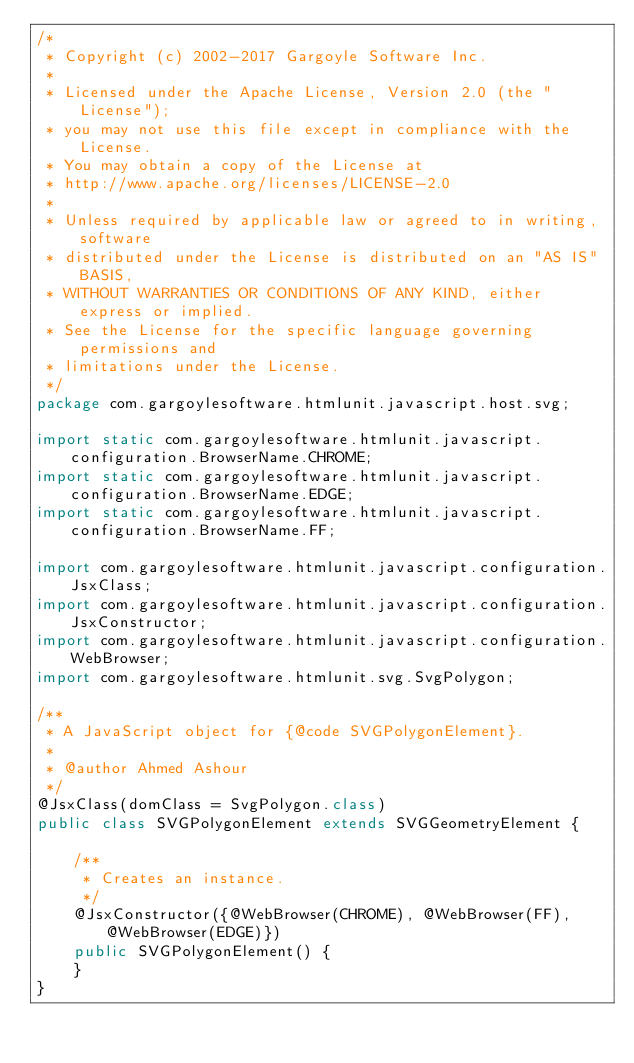Convert code to text. <code><loc_0><loc_0><loc_500><loc_500><_Java_>/*
 * Copyright (c) 2002-2017 Gargoyle Software Inc.
 *
 * Licensed under the Apache License, Version 2.0 (the "License");
 * you may not use this file except in compliance with the License.
 * You may obtain a copy of the License at
 * http://www.apache.org/licenses/LICENSE-2.0
 *
 * Unless required by applicable law or agreed to in writing, software
 * distributed under the License is distributed on an "AS IS" BASIS,
 * WITHOUT WARRANTIES OR CONDITIONS OF ANY KIND, either express or implied.
 * See the License for the specific language governing permissions and
 * limitations under the License.
 */
package com.gargoylesoftware.htmlunit.javascript.host.svg;

import static com.gargoylesoftware.htmlunit.javascript.configuration.BrowserName.CHROME;
import static com.gargoylesoftware.htmlunit.javascript.configuration.BrowserName.EDGE;
import static com.gargoylesoftware.htmlunit.javascript.configuration.BrowserName.FF;

import com.gargoylesoftware.htmlunit.javascript.configuration.JsxClass;
import com.gargoylesoftware.htmlunit.javascript.configuration.JsxConstructor;
import com.gargoylesoftware.htmlunit.javascript.configuration.WebBrowser;
import com.gargoylesoftware.htmlunit.svg.SvgPolygon;

/**
 * A JavaScript object for {@code SVGPolygonElement}.
 *
 * @author Ahmed Ashour
 */
@JsxClass(domClass = SvgPolygon.class)
public class SVGPolygonElement extends SVGGeometryElement {

    /**
     * Creates an instance.
     */
    @JsxConstructor({@WebBrowser(CHROME), @WebBrowser(FF), @WebBrowser(EDGE)})
    public SVGPolygonElement() {
    }
}
</code> 